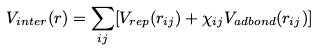Convert formula to latex. <formula><loc_0><loc_0><loc_500><loc_500>V _ { i n t e r } ( r ) = \sum _ { i j } [ V _ { r e p } ( r _ { i j } ) + \chi _ { i j } V _ { a d b o n d } ( r _ { i j } ) ]</formula> 